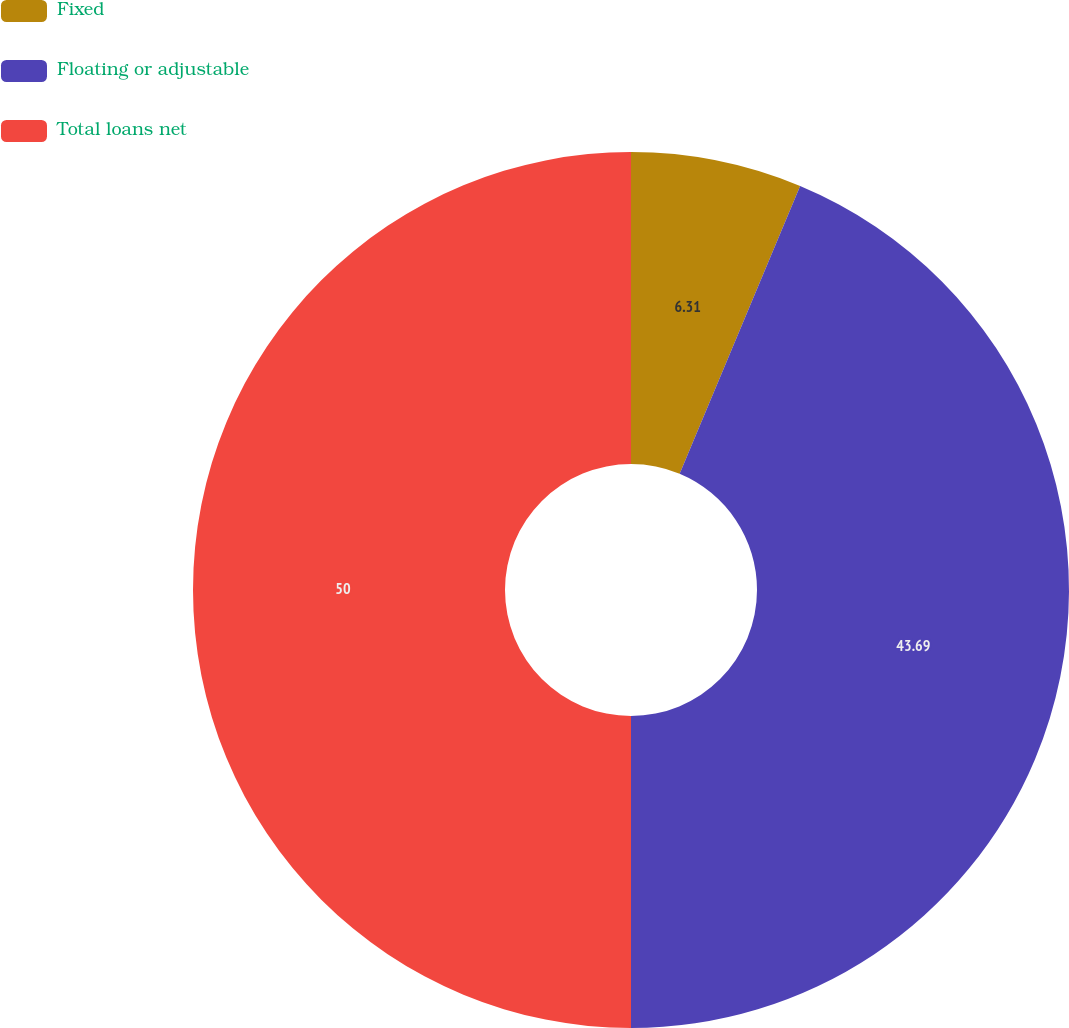<chart> <loc_0><loc_0><loc_500><loc_500><pie_chart><fcel>Fixed<fcel>Floating or adjustable<fcel>Total loans net<nl><fcel>6.31%<fcel>43.69%<fcel>50.0%<nl></chart> 